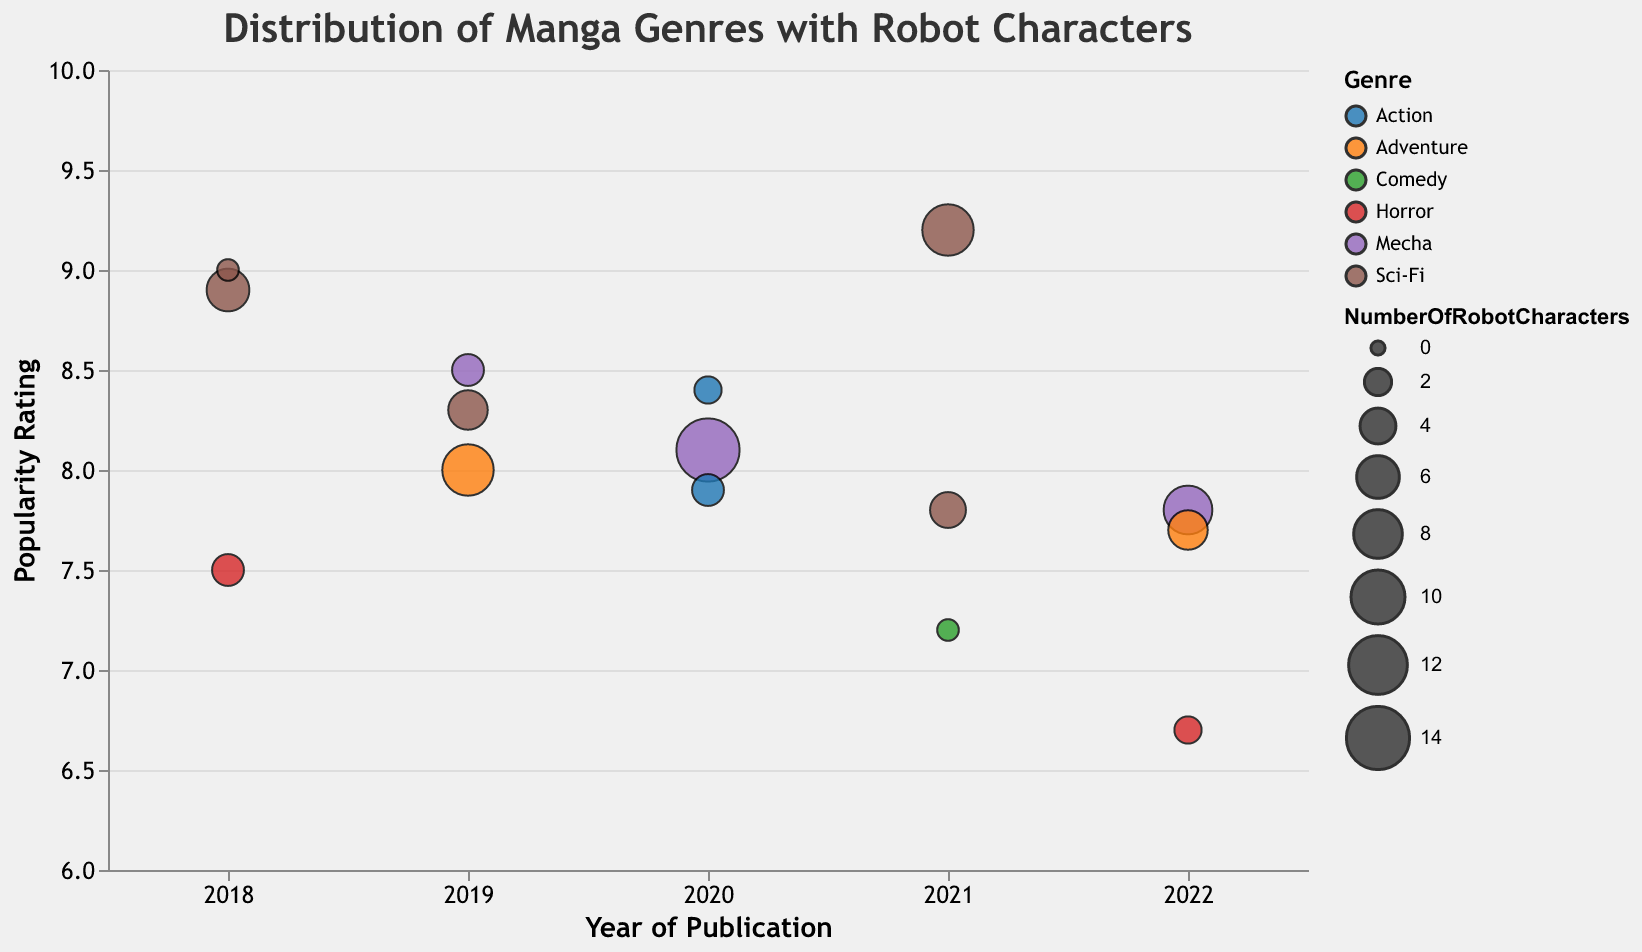What is the title of the chart? The title is displayed at the top of the chart in large font and clear text.
Answer: Distribution of Manga Genres with Robot Characters Which year has the manga with the highest popularity rating? The y-axis indicates the popularity rating, and by following the highest point on the y-axis to the corresponding year on the x-axis, we find the answer.
Answer: 2021 What genre has the manga with the greatest number of robot characters? The size of the circles represents the number of robot characters. The largest circle indicates the genre.
Answer: Mecha Which year has the most diverse set of manga genres? By observing the different colors (representing genres) along each year on the x-axis, we count the number of distinct colors per year.
Answer: 2019 What genre is "Paranoia Agent" and what is its popularity rating? By following the tooltip or the color key and respective bubble to the chart, we locate "Paranoia Agent" and read off its genre and popularity rating.
Answer: Horror, 6.7 Between 2018 and 2020, which genre appears the most frequently? Counting the distinct occurrences by genre for the years 2018, 2019, and 2020.
Answer: Sci-Fi How many robot characters does "Neon Genesis Evangelion" feature, and what's its popularity rating? Using the tooltip, locate "Neon Genesis Evangelion" to find the number of robot characters and the rating.
Answer: 9 characters, 9.2 Compare the popularity ratings of "Astro Boy" (2018) and "Acca 13 - Territory Inspection Dept." (2021). Which has a higher rating? Locate both mangas by their titles and compare the y-axis values (popularity ratings).
Answer: Astro Boy What is the average popularity rating of all 2019 manga entries on the chart? Sum the popularity ratings of all manga entries in 2019 and divide by the number of entries: (8.3 + 8.5 + 8.0 = 24.8) / 3.
Answer: 8.27 Which manga with robot characters has the lowest popularity rating, and what is that rating? Identify the lowest point on the y-axis and read the tooltip to find the title and rating.
Answer: Paranoia Agent, 6.7 